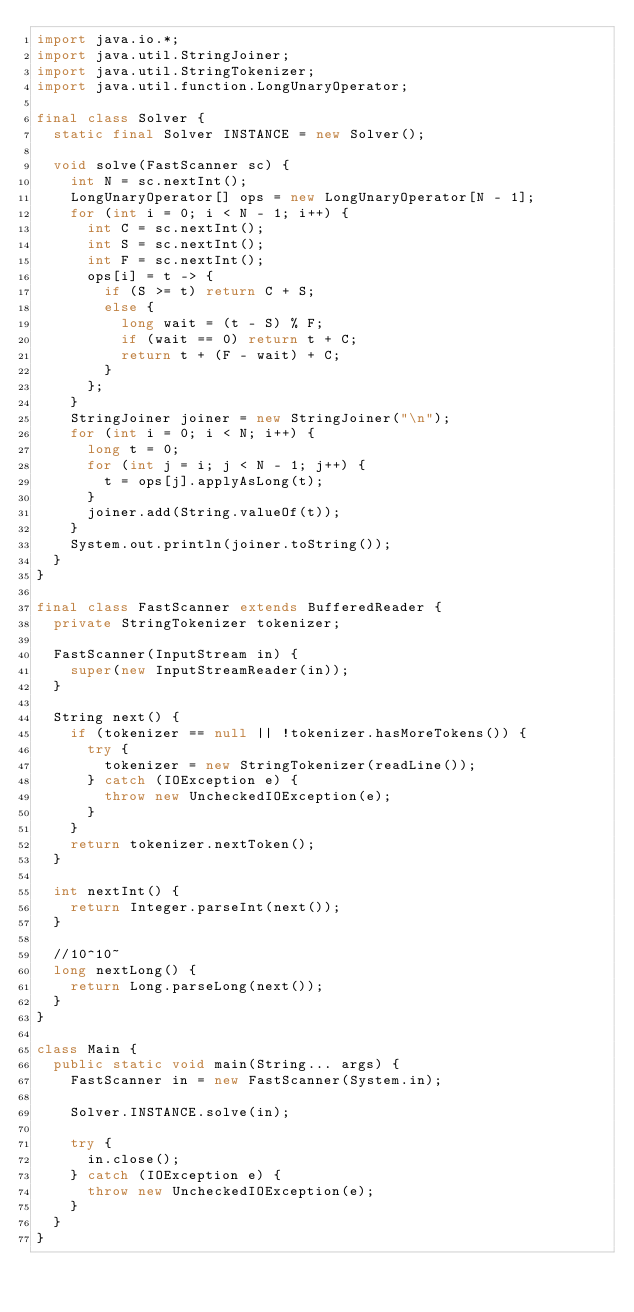Convert code to text. <code><loc_0><loc_0><loc_500><loc_500><_Java_>import java.io.*;
import java.util.StringJoiner;
import java.util.StringTokenizer;
import java.util.function.LongUnaryOperator;

final class Solver {
	static final Solver INSTANCE = new Solver();

	void solve(FastScanner sc) {
		int N = sc.nextInt();
		LongUnaryOperator[] ops = new LongUnaryOperator[N - 1];
		for (int i = 0; i < N - 1; i++) {
			int C = sc.nextInt();
			int S = sc.nextInt();
			int F = sc.nextInt();
			ops[i] = t -> {
				if (S >= t) return C + S;
				else {
					long wait = (t - S) % F;
					if (wait == 0) return t + C;
					return t + (F - wait) + C;
				}
			};
		}
		StringJoiner joiner = new StringJoiner("\n");
		for (int i = 0; i < N; i++) {
			long t = 0;
			for (int j = i; j < N - 1; j++) {
				t = ops[j].applyAsLong(t);
			}
			joiner.add(String.valueOf(t));
		}
		System.out.println(joiner.toString());
	}
}

final class FastScanner extends BufferedReader {
	private StringTokenizer tokenizer;

	FastScanner(InputStream in) {
		super(new InputStreamReader(in));
	}

	String next() {
		if (tokenizer == null || !tokenizer.hasMoreTokens()) {
			try {
				tokenizer = new StringTokenizer(readLine());
			} catch (IOException e) {
				throw new UncheckedIOException(e);
			}
		}
		return tokenizer.nextToken();
	}

	int nextInt() {
		return Integer.parseInt(next());
	}

	//10^10~
	long nextLong() {
		return Long.parseLong(next());
	}
}

class Main {
	public static void main(String... args) {
		FastScanner in = new FastScanner(System.in);

		Solver.INSTANCE.solve(in);

		try {
			in.close();
		} catch (IOException e) {
			throw new UncheckedIOException(e);
		}
	}
}</code> 